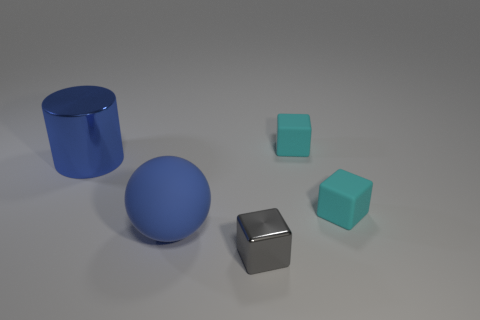There is a large object that is to the left of the large matte object; does it have the same color as the large matte object in front of the large metallic cylinder?
Make the answer very short. Yes. Are there more rubber balls in front of the large metal cylinder than large brown balls?
Provide a succinct answer. Yes. What is the material of the blue cylinder?
Your answer should be compact. Metal. There is a object that is the same material as the blue cylinder; what shape is it?
Keep it short and to the point. Cube. How big is the blue thing in front of the shiny object that is behind the small shiny object?
Give a very brief answer. Large. There is a shiny thing that is left of the tiny gray block; what is its color?
Provide a short and direct response. Blue. Is there another big object that has the same shape as the big blue shiny thing?
Offer a terse response. No. Are there fewer gray metallic blocks to the left of the small metallic thing than cyan matte things in front of the large metal cylinder?
Offer a terse response. Yes. What color is the ball?
Make the answer very short. Blue. There is a cyan thing that is in front of the big cylinder; is there a tiny cyan rubber thing on the left side of it?
Provide a short and direct response. Yes. 